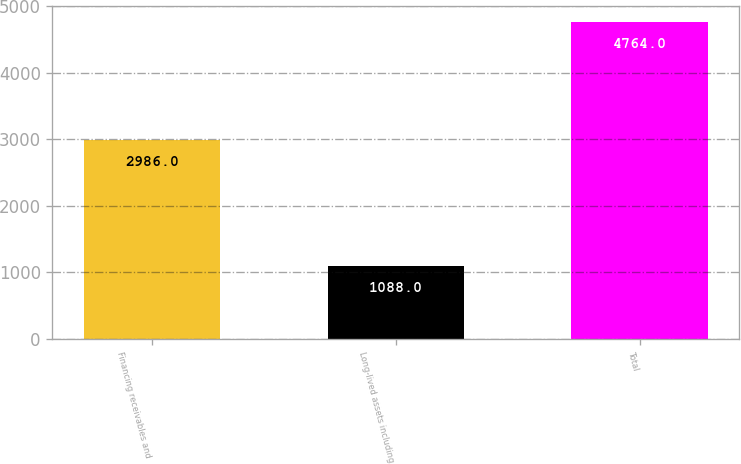Convert chart. <chart><loc_0><loc_0><loc_500><loc_500><bar_chart><fcel>Financing receivables and<fcel>Long-lived assets including<fcel>Total<nl><fcel>2986<fcel>1088<fcel>4764<nl></chart> 